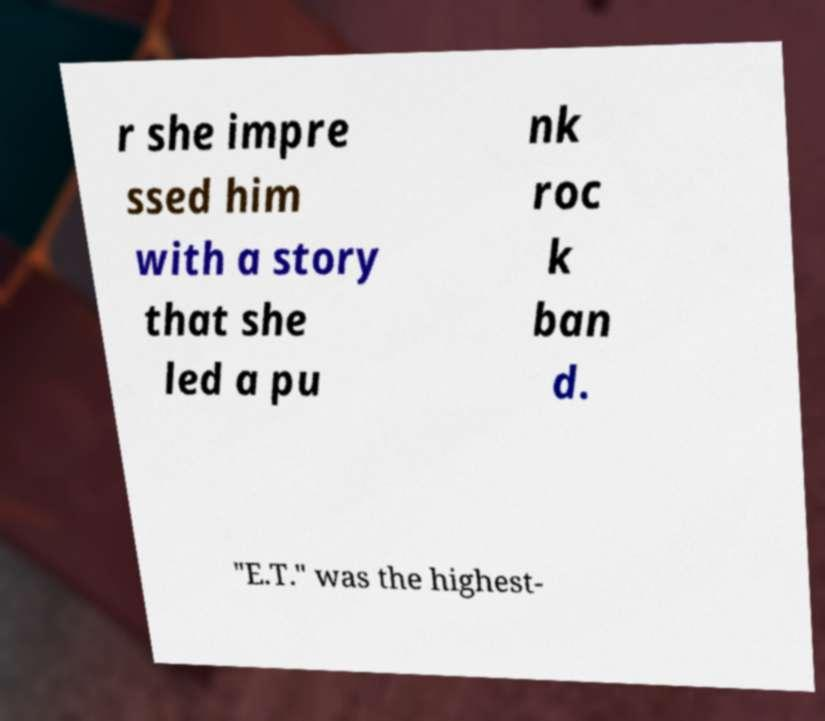Please identify and transcribe the text found in this image. r she impre ssed him with a story that she led a pu nk roc k ban d. "E.T." was the highest- 